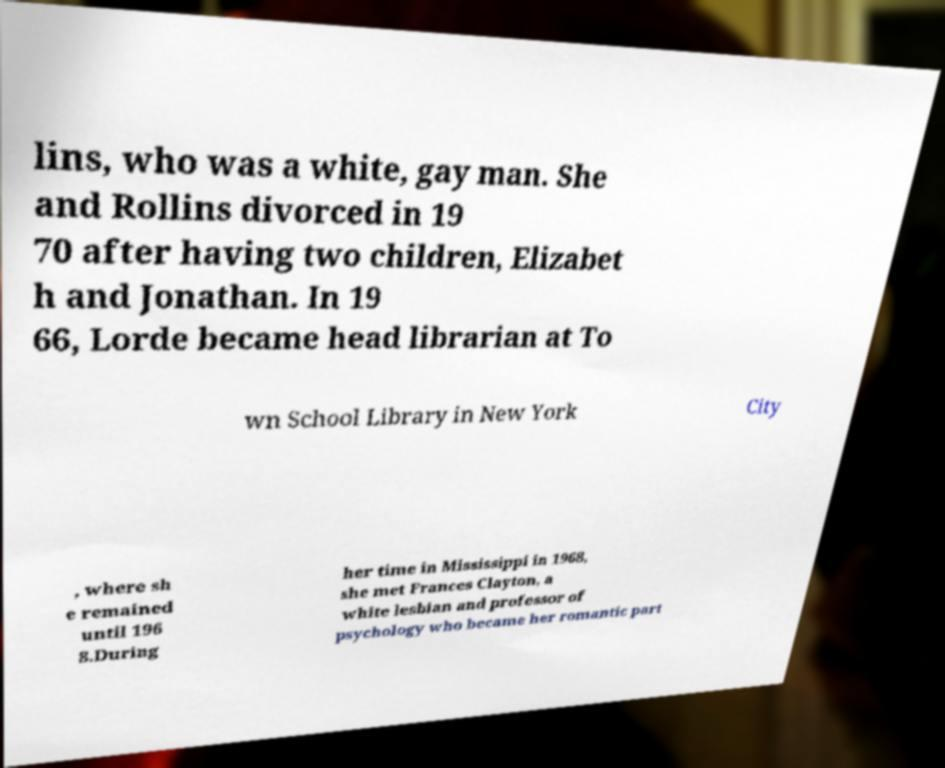There's text embedded in this image that I need extracted. Can you transcribe it verbatim? lins, who was a white, gay man. She and Rollins divorced in 19 70 after having two children, Elizabet h and Jonathan. In 19 66, Lorde became head librarian at To wn School Library in New York City , where sh e remained until 196 8.During her time in Mississippi in 1968, she met Frances Clayton, a white lesbian and professor of psychology who became her romantic part 